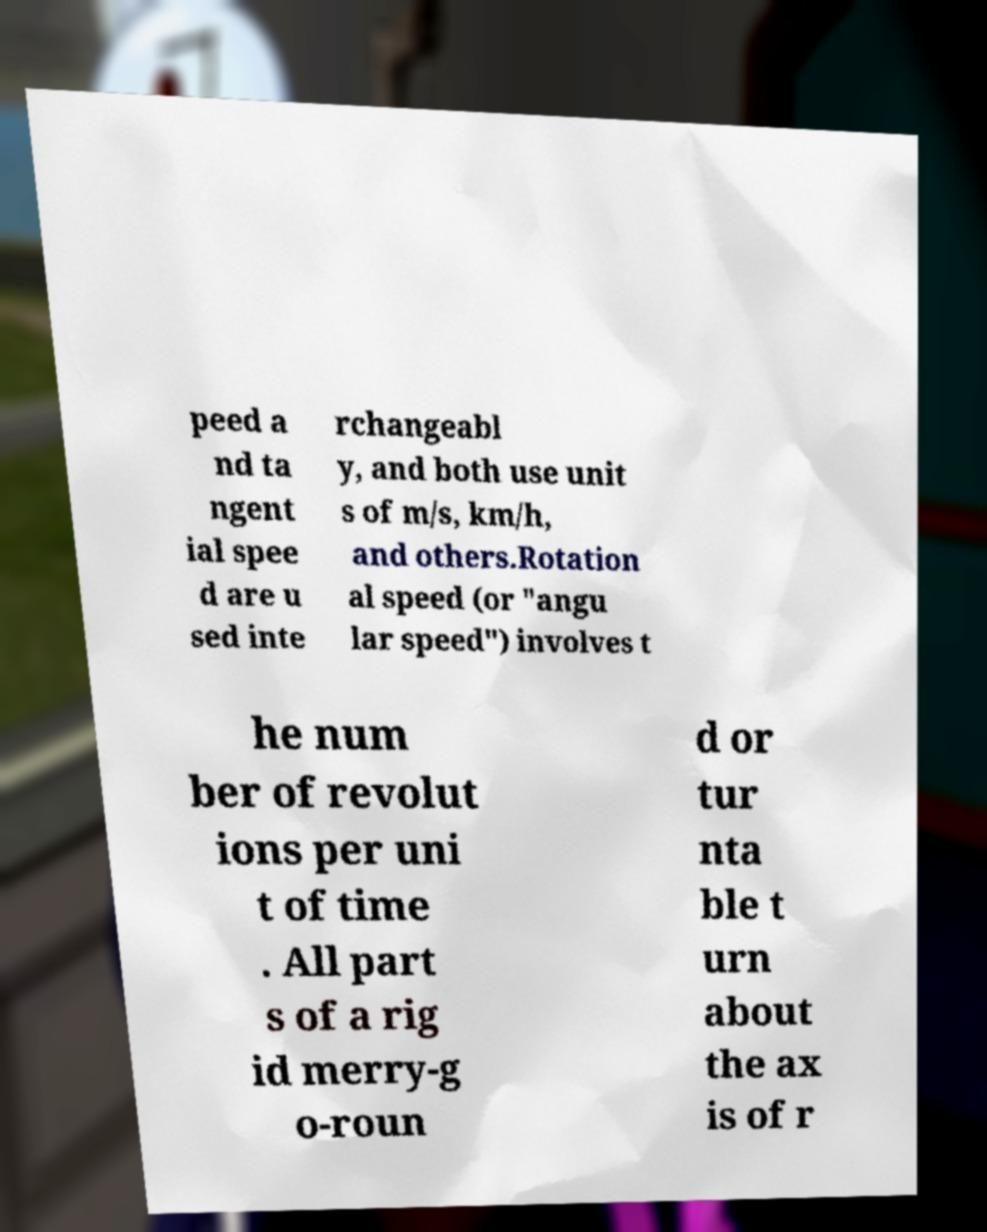What messages or text are displayed in this image? I need them in a readable, typed format. peed a nd ta ngent ial spee d are u sed inte rchangeabl y, and both use unit s of m/s, km/h, and others.Rotation al speed (or "angu lar speed") involves t he num ber of revolut ions per uni t of time . All part s of a rig id merry-g o-roun d or tur nta ble t urn about the ax is of r 